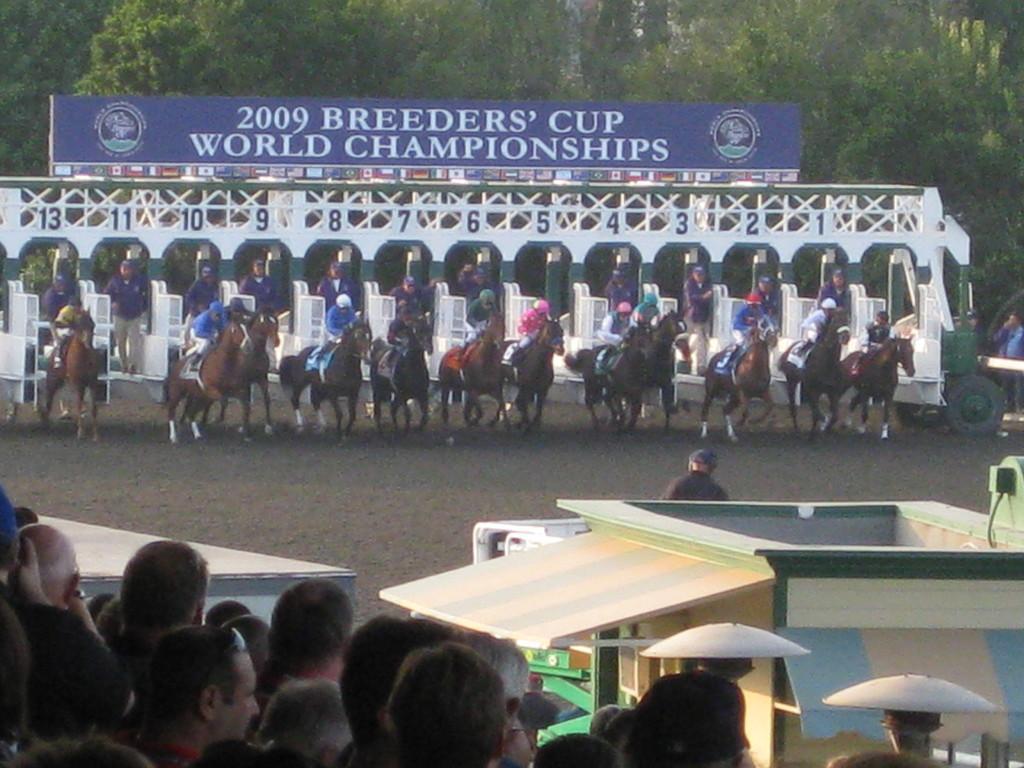How would you summarize this image in a sentence or two? In this image I can see group of people sitting on the horses and the horses are in brown color. In the background I can see the board in blue color and I can also see few trees in green color. In front I can see group of people sitting. 